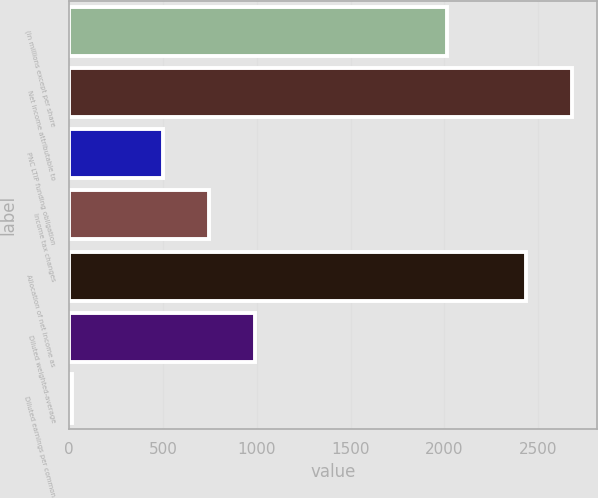Convert chart. <chart><loc_0><loc_0><loc_500><loc_500><bar_chart><fcel>(in millions except per share<fcel>Net income attributable to<fcel>PNC LTIP funding obligation<fcel>Income tax changes<fcel>Allocation of net income as<fcel>Diluted weighted-average<fcel>Diluted earnings per common<nl><fcel>2012<fcel>2679.43<fcel>502.54<fcel>746.97<fcel>2435<fcel>991.4<fcel>13.68<nl></chart> 